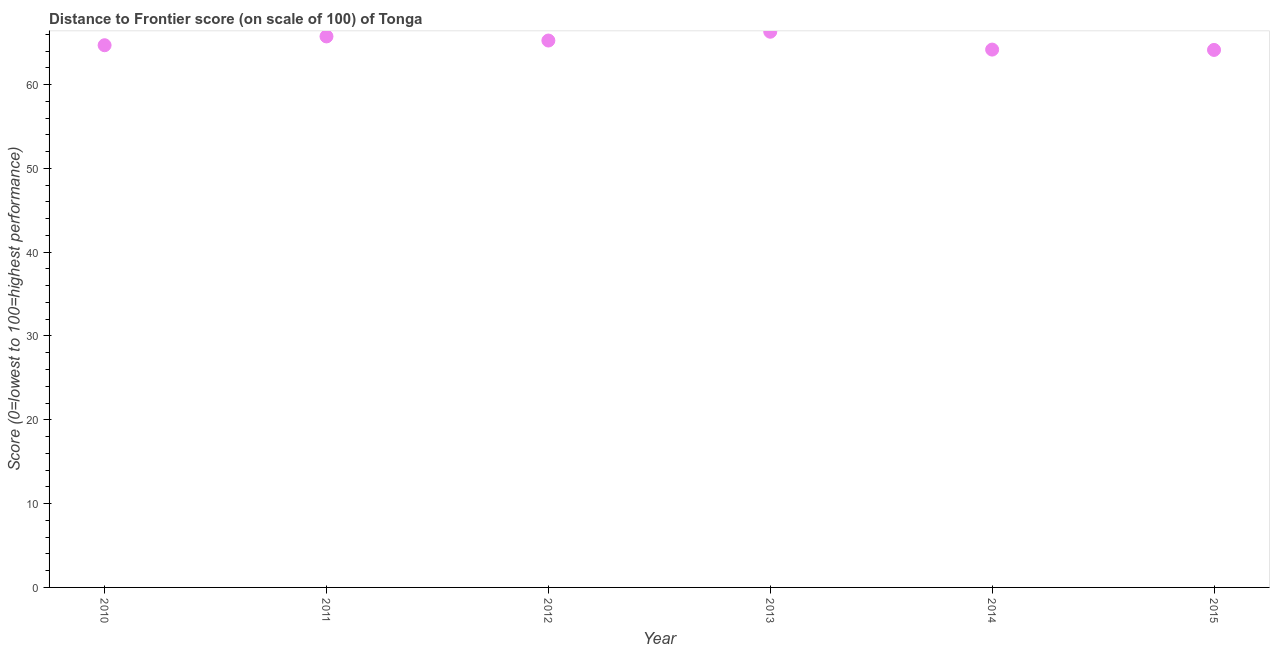What is the distance to frontier score in 2013?
Provide a short and direct response. 66.3. Across all years, what is the maximum distance to frontier score?
Ensure brevity in your answer.  66.3. Across all years, what is the minimum distance to frontier score?
Provide a succinct answer. 64.13. In which year was the distance to frontier score maximum?
Offer a terse response. 2013. In which year was the distance to frontier score minimum?
Offer a terse response. 2015. What is the sum of the distance to frontier score?
Provide a succinct answer. 390.28. What is the difference between the distance to frontier score in 2011 and 2015?
Your response must be concise. 1.61. What is the average distance to frontier score per year?
Keep it short and to the point. 65.05. What is the median distance to frontier score?
Keep it short and to the point. 64.97. In how many years, is the distance to frontier score greater than 8 ?
Give a very brief answer. 6. Do a majority of the years between 2011 and 2013 (inclusive) have distance to frontier score greater than 36 ?
Offer a terse response. Yes. What is the ratio of the distance to frontier score in 2013 to that in 2015?
Give a very brief answer. 1.03. What is the difference between the highest and the second highest distance to frontier score?
Offer a very short reply. 0.56. What is the difference between the highest and the lowest distance to frontier score?
Offer a terse response. 2.17. In how many years, is the distance to frontier score greater than the average distance to frontier score taken over all years?
Give a very brief answer. 3. Does the distance to frontier score monotonically increase over the years?
Make the answer very short. No. Does the graph contain any zero values?
Your answer should be very brief. No. Does the graph contain grids?
Offer a terse response. No. What is the title of the graph?
Offer a very short reply. Distance to Frontier score (on scale of 100) of Tonga. What is the label or title of the X-axis?
Provide a short and direct response. Year. What is the label or title of the Y-axis?
Give a very brief answer. Score (0=lowest to 100=highest performance). What is the Score (0=lowest to 100=highest performance) in 2010?
Make the answer very short. 64.69. What is the Score (0=lowest to 100=highest performance) in 2011?
Your answer should be very brief. 65.74. What is the Score (0=lowest to 100=highest performance) in 2012?
Provide a short and direct response. 65.25. What is the Score (0=lowest to 100=highest performance) in 2013?
Your response must be concise. 66.3. What is the Score (0=lowest to 100=highest performance) in 2014?
Your answer should be very brief. 64.17. What is the Score (0=lowest to 100=highest performance) in 2015?
Make the answer very short. 64.13. What is the difference between the Score (0=lowest to 100=highest performance) in 2010 and 2011?
Keep it short and to the point. -1.05. What is the difference between the Score (0=lowest to 100=highest performance) in 2010 and 2012?
Provide a succinct answer. -0.56. What is the difference between the Score (0=lowest to 100=highest performance) in 2010 and 2013?
Ensure brevity in your answer.  -1.61. What is the difference between the Score (0=lowest to 100=highest performance) in 2010 and 2014?
Your answer should be very brief. 0.52. What is the difference between the Score (0=lowest to 100=highest performance) in 2010 and 2015?
Your response must be concise. 0.56. What is the difference between the Score (0=lowest to 100=highest performance) in 2011 and 2012?
Your answer should be compact. 0.49. What is the difference between the Score (0=lowest to 100=highest performance) in 2011 and 2013?
Your response must be concise. -0.56. What is the difference between the Score (0=lowest to 100=highest performance) in 2011 and 2014?
Give a very brief answer. 1.57. What is the difference between the Score (0=lowest to 100=highest performance) in 2011 and 2015?
Ensure brevity in your answer.  1.61. What is the difference between the Score (0=lowest to 100=highest performance) in 2012 and 2013?
Offer a terse response. -1.05. What is the difference between the Score (0=lowest to 100=highest performance) in 2012 and 2014?
Provide a short and direct response. 1.08. What is the difference between the Score (0=lowest to 100=highest performance) in 2012 and 2015?
Provide a succinct answer. 1.12. What is the difference between the Score (0=lowest to 100=highest performance) in 2013 and 2014?
Keep it short and to the point. 2.13. What is the difference between the Score (0=lowest to 100=highest performance) in 2013 and 2015?
Your answer should be very brief. 2.17. What is the ratio of the Score (0=lowest to 100=highest performance) in 2010 to that in 2011?
Keep it short and to the point. 0.98. What is the ratio of the Score (0=lowest to 100=highest performance) in 2010 to that in 2012?
Give a very brief answer. 0.99. What is the ratio of the Score (0=lowest to 100=highest performance) in 2011 to that in 2012?
Offer a very short reply. 1.01. What is the ratio of the Score (0=lowest to 100=highest performance) in 2011 to that in 2014?
Your response must be concise. 1.02. What is the ratio of the Score (0=lowest to 100=highest performance) in 2011 to that in 2015?
Give a very brief answer. 1.02. What is the ratio of the Score (0=lowest to 100=highest performance) in 2012 to that in 2014?
Give a very brief answer. 1.02. What is the ratio of the Score (0=lowest to 100=highest performance) in 2013 to that in 2014?
Your answer should be compact. 1.03. What is the ratio of the Score (0=lowest to 100=highest performance) in 2013 to that in 2015?
Keep it short and to the point. 1.03. What is the ratio of the Score (0=lowest to 100=highest performance) in 2014 to that in 2015?
Your response must be concise. 1. 